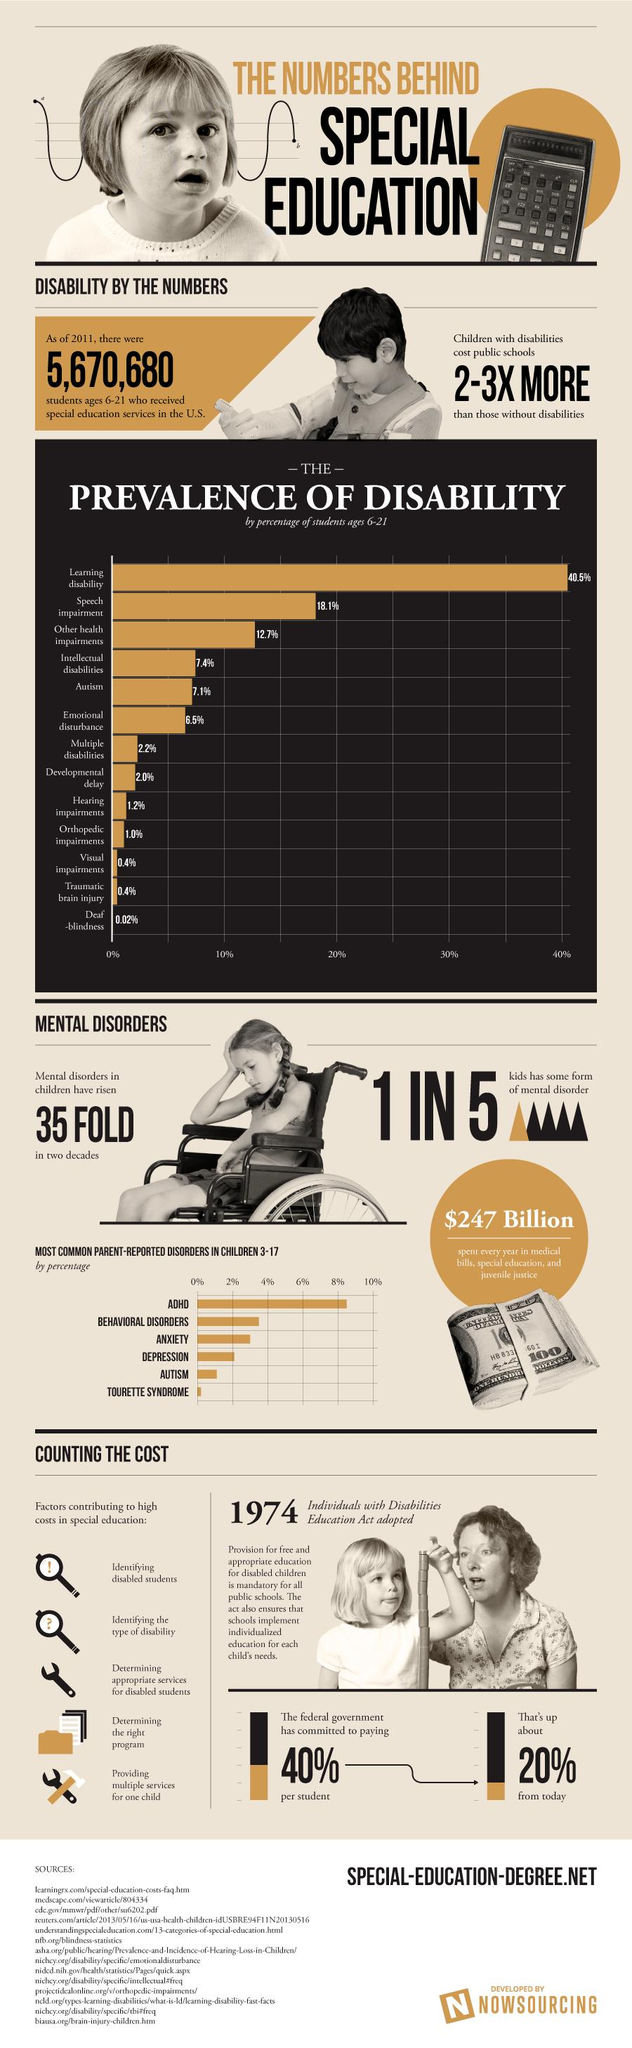Outline some significant characteristics in this image. Of the disabilities with a prevalence of disability by percentage greater than 18%, there are 2. Of the 5 children, how many do not have a mental disorder? 4 of them do not have a mental disorder. Six parent-reported disorders were mentioned in this infographic. It is estimated that there are approximately 2 disabilities with a prevalence of disability between 7 and 7.5%. 